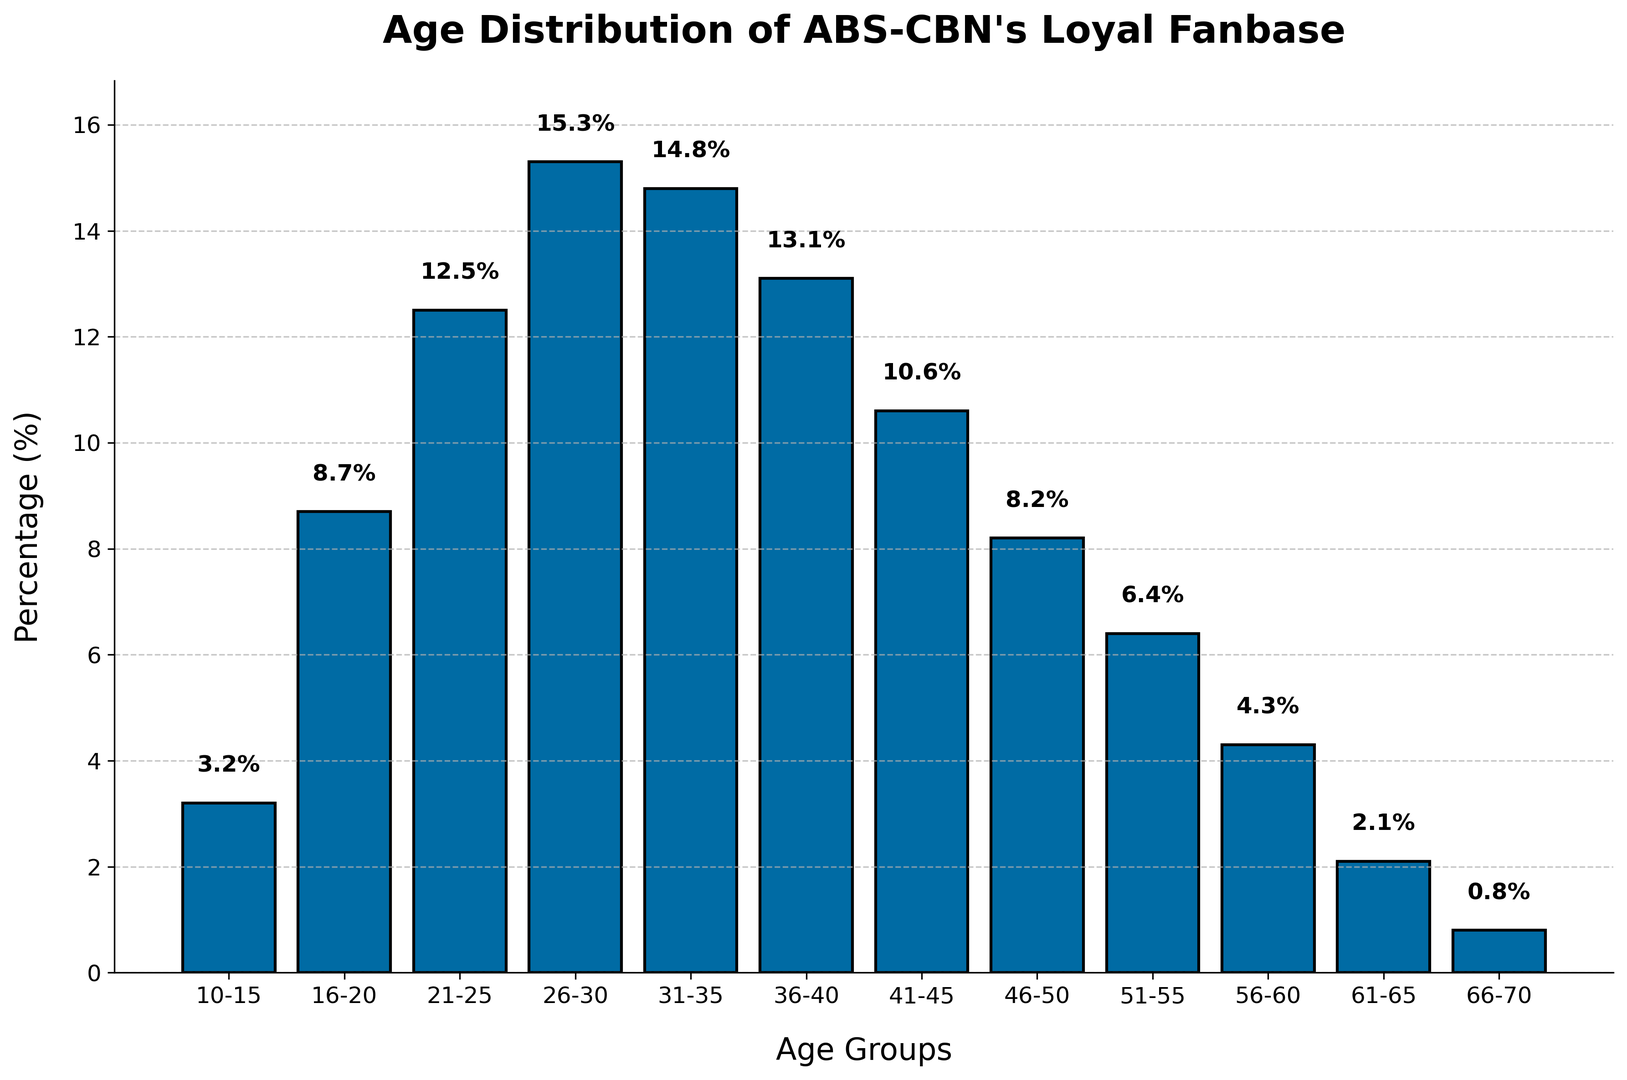What age group has the highest percentage of loyal fans? The age group with the highest percentage can be identified by finding the tallest bar in the histogram. The 26-30 age group has the highest percentage at 15.3%.
Answer: 26-30 Which age group has the lowest percentage of loyal fans? The age group with the lowest percentage can be identified by finding the smallest bar in the histogram. The 66-70 age group has the lowest percentage at 0.8%.
Answer: 66-70 What is the total percentage of loyal fans aged between 21-30? Sum the percentages of age groups 21-25 and 26-30. So, 12.5% + 15.3% = 27.8%.
Answer: 27.8% How much higher is the percentage of loyal fans in the 26-30 age group compared to the 16-20 age group? Subtract the percentage of the 16-20 age group from the percentage of the 26-30 age group. So, 15.3% - 8.7% = 6.6%.
Answer: 6.6% What is the average percentage of loyal fans in the age groups 31-35, 36-40, and 41-45? Add the percentages of the three age groups and then divide by 3. So, (14.8% + 13.1% + 10.6%) / 3 = 12.83% (approx).
Answer: 12.83% Which age group has a percentage closest to 10%? Find the age group whose percentage is closest to 10%. The 41-45 age group has a percentage of 10.6%, which is closest to 10%.
Answer: 41-45 Compare the sum of percentages for the age groups below 20 and above 50. Which is greater? First sum the percentages of age groups 10-15 and 16-20: 3.2% + 8.7% = 11.9%. Then sum the percentages of age groups 51-55, 56-60, and 61-65, 66-70: 6.4% + 4.3% + 2.1% + 0.8% = 13.6%. The sum for age groups above 50 is greater.
Answer: Above 50 Which age groups account for more than 10% of the loyal fanbase? Identify all age groups with percentages greater than 10%. These are 21-25 (12.5%), 26-30 (15.3%), 31-35 (14.8%), and 36-40 (13.1%), and 41-45 (10.6%).
Answer: 21-25, 26-30, 31-35, 36-40, 41-45 What is the combined percentage of loyal fans in the 46-50 and 51-55 age groups? Add the percentages of the 46-50 and 51-55 age groups. So, 8.2% + 6.4% = 14.6%.
Answer: 14.6% Describe the overall trend in the age distribution of ABS-CBN's loyal fanbase. The percentages generally increase up to the 26-30 age group, then slowly decrease as the age increases. The middle-aged (26-35) have the highest percentages, while both younger and older age groups have lower percentages.
Answer: Middle-aged groups have the highest percentages, others lower 